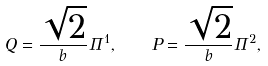<formula> <loc_0><loc_0><loc_500><loc_500>Q = \frac { \sqrt { 2 } } b \Pi ^ { 1 } , \quad P = \frac { \sqrt { 2 } } b \Pi ^ { 2 } ,</formula> 